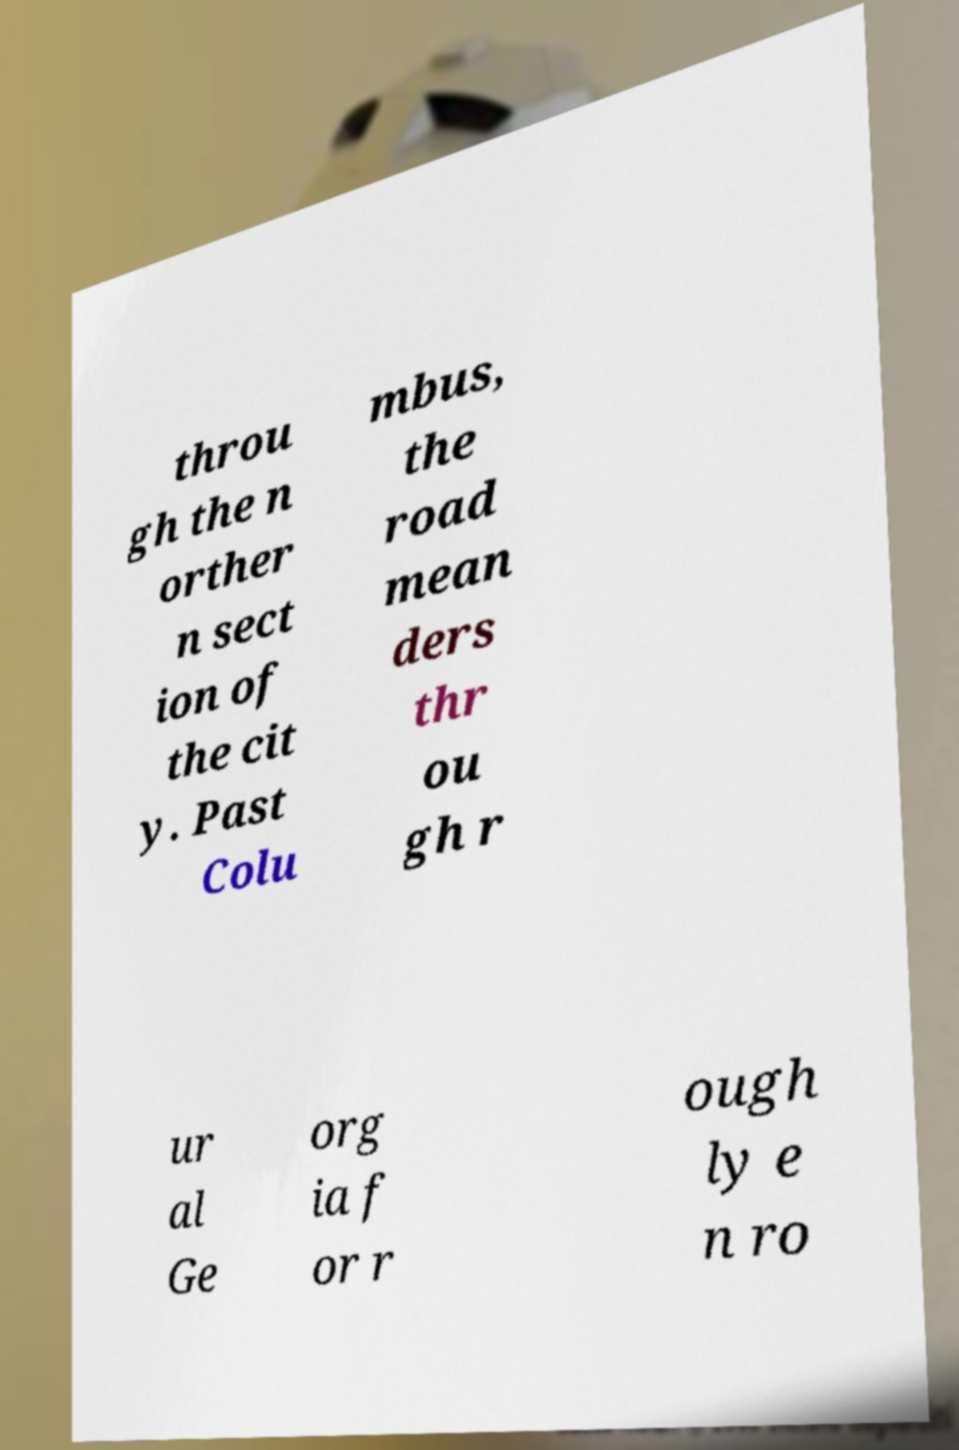Please identify and transcribe the text found in this image. throu gh the n orther n sect ion of the cit y. Past Colu mbus, the road mean ders thr ou gh r ur al Ge org ia f or r ough ly e n ro 